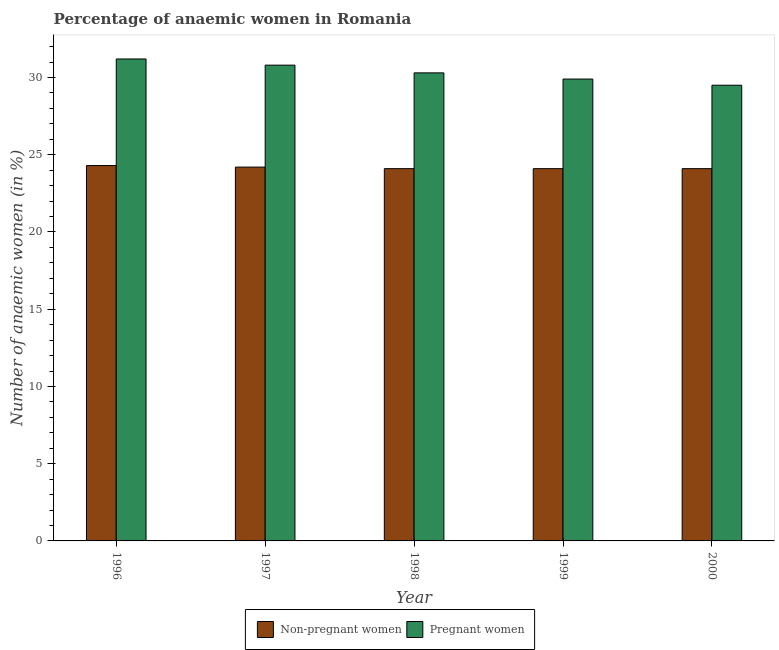How many different coloured bars are there?
Provide a short and direct response. 2. How many groups of bars are there?
Offer a terse response. 5. How many bars are there on the 4th tick from the right?
Give a very brief answer. 2. What is the label of the 3rd group of bars from the left?
Ensure brevity in your answer.  1998. In how many cases, is the number of bars for a given year not equal to the number of legend labels?
Your response must be concise. 0. What is the percentage of non-pregnant anaemic women in 1997?
Offer a terse response. 24.2. Across all years, what is the maximum percentage of pregnant anaemic women?
Provide a succinct answer. 31.2. Across all years, what is the minimum percentage of pregnant anaemic women?
Offer a very short reply. 29.5. What is the total percentage of pregnant anaemic women in the graph?
Provide a short and direct response. 151.7. What is the difference between the percentage of pregnant anaemic women in 1996 and that in 1997?
Provide a succinct answer. 0.4. What is the difference between the percentage of pregnant anaemic women in 1996 and the percentage of non-pregnant anaemic women in 1999?
Give a very brief answer. 1.3. What is the average percentage of non-pregnant anaemic women per year?
Your answer should be very brief. 24.16. In the year 1997, what is the difference between the percentage of pregnant anaemic women and percentage of non-pregnant anaemic women?
Make the answer very short. 0. What is the ratio of the percentage of pregnant anaemic women in 1997 to that in 2000?
Ensure brevity in your answer.  1.04. Is the difference between the percentage of pregnant anaemic women in 1996 and 1997 greater than the difference between the percentage of non-pregnant anaemic women in 1996 and 1997?
Give a very brief answer. No. What is the difference between the highest and the second highest percentage of pregnant anaemic women?
Make the answer very short. 0.4. What is the difference between the highest and the lowest percentage of non-pregnant anaemic women?
Provide a succinct answer. 0.2. Is the sum of the percentage of non-pregnant anaemic women in 1996 and 1999 greater than the maximum percentage of pregnant anaemic women across all years?
Make the answer very short. Yes. What does the 1st bar from the left in 1996 represents?
Offer a terse response. Non-pregnant women. What does the 2nd bar from the right in 1998 represents?
Ensure brevity in your answer.  Non-pregnant women. Are the values on the major ticks of Y-axis written in scientific E-notation?
Give a very brief answer. No. Does the graph contain any zero values?
Your response must be concise. No. How are the legend labels stacked?
Ensure brevity in your answer.  Horizontal. What is the title of the graph?
Provide a succinct answer. Percentage of anaemic women in Romania. Does "Automatic Teller Machines" appear as one of the legend labels in the graph?
Your answer should be compact. No. What is the label or title of the X-axis?
Provide a succinct answer. Year. What is the label or title of the Y-axis?
Your response must be concise. Number of anaemic women (in %). What is the Number of anaemic women (in %) of Non-pregnant women in 1996?
Your answer should be compact. 24.3. What is the Number of anaemic women (in %) in Pregnant women in 1996?
Make the answer very short. 31.2. What is the Number of anaemic women (in %) of Non-pregnant women in 1997?
Make the answer very short. 24.2. What is the Number of anaemic women (in %) of Pregnant women in 1997?
Your response must be concise. 30.8. What is the Number of anaemic women (in %) in Non-pregnant women in 1998?
Provide a succinct answer. 24.1. What is the Number of anaemic women (in %) of Pregnant women in 1998?
Your response must be concise. 30.3. What is the Number of anaemic women (in %) in Non-pregnant women in 1999?
Keep it short and to the point. 24.1. What is the Number of anaemic women (in %) of Pregnant women in 1999?
Provide a succinct answer. 29.9. What is the Number of anaemic women (in %) in Non-pregnant women in 2000?
Your answer should be very brief. 24.1. What is the Number of anaemic women (in %) in Pregnant women in 2000?
Provide a short and direct response. 29.5. Across all years, what is the maximum Number of anaemic women (in %) in Non-pregnant women?
Your response must be concise. 24.3. Across all years, what is the maximum Number of anaemic women (in %) of Pregnant women?
Your answer should be very brief. 31.2. Across all years, what is the minimum Number of anaemic women (in %) of Non-pregnant women?
Provide a succinct answer. 24.1. Across all years, what is the minimum Number of anaemic women (in %) in Pregnant women?
Provide a short and direct response. 29.5. What is the total Number of anaemic women (in %) in Non-pregnant women in the graph?
Your answer should be very brief. 120.8. What is the total Number of anaemic women (in %) in Pregnant women in the graph?
Provide a short and direct response. 151.7. What is the difference between the Number of anaemic women (in %) of Non-pregnant women in 1996 and that in 1997?
Provide a short and direct response. 0.1. What is the difference between the Number of anaemic women (in %) in Pregnant women in 1996 and that in 1997?
Offer a very short reply. 0.4. What is the difference between the Number of anaemic women (in %) of Pregnant women in 1996 and that in 1998?
Your answer should be compact. 0.9. What is the difference between the Number of anaemic women (in %) of Non-pregnant women in 1996 and that in 1999?
Ensure brevity in your answer.  0.2. What is the difference between the Number of anaemic women (in %) of Pregnant women in 1996 and that in 1999?
Make the answer very short. 1.3. What is the difference between the Number of anaemic women (in %) in Pregnant women in 1997 and that in 1998?
Provide a short and direct response. 0.5. What is the difference between the Number of anaemic women (in %) of Non-pregnant women in 1997 and that in 1999?
Provide a short and direct response. 0.1. What is the difference between the Number of anaemic women (in %) of Pregnant women in 1997 and that in 1999?
Give a very brief answer. 0.9. What is the difference between the Number of anaemic women (in %) of Non-pregnant women in 1997 and that in 2000?
Give a very brief answer. 0.1. What is the difference between the Number of anaemic women (in %) of Non-pregnant women in 1998 and that in 1999?
Offer a very short reply. 0. What is the difference between the Number of anaemic women (in %) in Pregnant women in 1998 and that in 2000?
Make the answer very short. 0.8. What is the difference between the Number of anaemic women (in %) in Pregnant women in 1999 and that in 2000?
Keep it short and to the point. 0.4. What is the difference between the Number of anaemic women (in %) in Non-pregnant women in 1996 and the Number of anaemic women (in %) in Pregnant women in 1998?
Your answer should be very brief. -6. What is the difference between the Number of anaemic women (in %) in Non-pregnant women in 1997 and the Number of anaemic women (in %) in Pregnant women in 1999?
Keep it short and to the point. -5.7. What is the difference between the Number of anaemic women (in %) of Non-pregnant women in 1997 and the Number of anaemic women (in %) of Pregnant women in 2000?
Provide a succinct answer. -5.3. What is the difference between the Number of anaemic women (in %) of Non-pregnant women in 1999 and the Number of anaemic women (in %) of Pregnant women in 2000?
Keep it short and to the point. -5.4. What is the average Number of anaemic women (in %) of Non-pregnant women per year?
Your response must be concise. 24.16. What is the average Number of anaemic women (in %) in Pregnant women per year?
Offer a terse response. 30.34. In the year 1996, what is the difference between the Number of anaemic women (in %) of Non-pregnant women and Number of anaemic women (in %) of Pregnant women?
Offer a terse response. -6.9. In the year 2000, what is the difference between the Number of anaemic women (in %) in Non-pregnant women and Number of anaemic women (in %) in Pregnant women?
Provide a short and direct response. -5.4. What is the ratio of the Number of anaemic women (in %) in Non-pregnant women in 1996 to that in 1997?
Keep it short and to the point. 1. What is the ratio of the Number of anaemic women (in %) of Pregnant women in 1996 to that in 1997?
Make the answer very short. 1.01. What is the ratio of the Number of anaemic women (in %) in Non-pregnant women in 1996 to that in 1998?
Provide a succinct answer. 1.01. What is the ratio of the Number of anaemic women (in %) of Pregnant women in 1996 to that in 1998?
Make the answer very short. 1.03. What is the ratio of the Number of anaemic women (in %) of Non-pregnant women in 1996 to that in 1999?
Your answer should be very brief. 1.01. What is the ratio of the Number of anaemic women (in %) of Pregnant women in 1996 to that in 1999?
Make the answer very short. 1.04. What is the ratio of the Number of anaemic women (in %) of Non-pregnant women in 1996 to that in 2000?
Your answer should be very brief. 1.01. What is the ratio of the Number of anaemic women (in %) in Pregnant women in 1996 to that in 2000?
Your answer should be very brief. 1.06. What is the ratio of the Number of anaemic women (in %) of Non-pregnant women in 1997 to that in 1998?
Keep it short and to the point. 1. What is the ratio of the Number of anaemic women (in %) in Pregnant women in 1997 to that in 1998?
Your answer should be compact. 1.02. What is the ratio of the Number of anaemic women (in %) in Pregnant women in 1997 to that in 1999?
Your answer should be very brief. 1.03. What is the ratio of the Number of anaemic women (in %) in Pregnant women in 1997 to that in 2000?
Make the answer very short. 1.04. What is the ratio of the Number of anaemic women (in %) in Pregnant women in 1998 to that in 1999?
Provide a short and direct response. 1.01. What is the ratio of the Number of anaemic women (in %) in Pregnant women in 1998 to that in 2000?
Provide a short and direct response. 1.03. What is the ratio of the Number of anaemic women (in %) of Non-pregnant women in 1999 to that in 2000?
Offer a very short reply. 1. What is the ratio of the Number of anaemic women (in %) of Pregnant women in 1999 to that in 2000?
Provide a short and direct response. 1.01. What is the difference between the highest and the second highest Number of anaemic women (in %) of Non-pregnant women?
Your response must be concise. 0.1. What is the difference between the highest and the lowest Number of anaemic women (in %) in Pregnant women?
Ensure brevity in your answer.  1.7. 